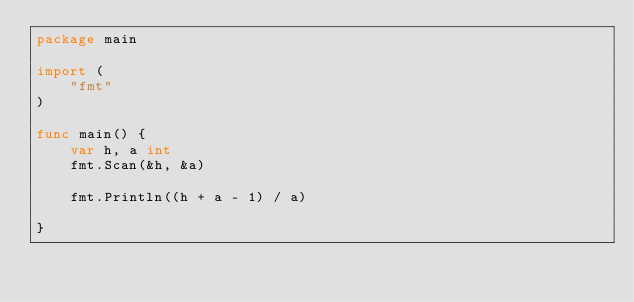<code> <loc_0><loc_0><loc_500><loc_500><_Go_>package main

import (
	"fmt"
)

func main() {
	var h, a int
	fmt.Scan(&h, &a)

	fmt.Println((h + a - 1) / a)

}
</code> 